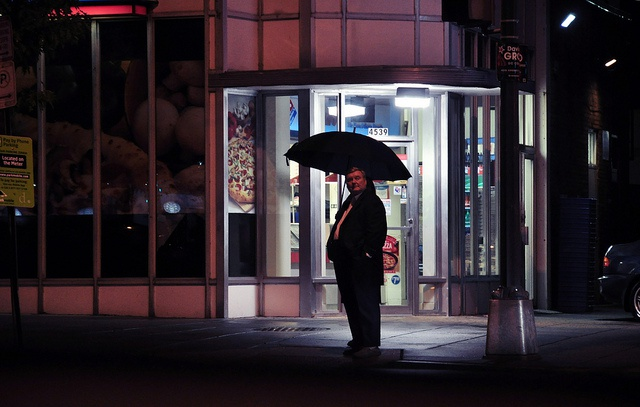Describe the objects in this image and their specific colors. I can see people in black, maroon, brown, and gray tones, umbrella in black, lightgray, darkgray, and gray tones, car in black, maroon, and gray tones, and tie in black, brown, maroon, and salmon tones in this image. 